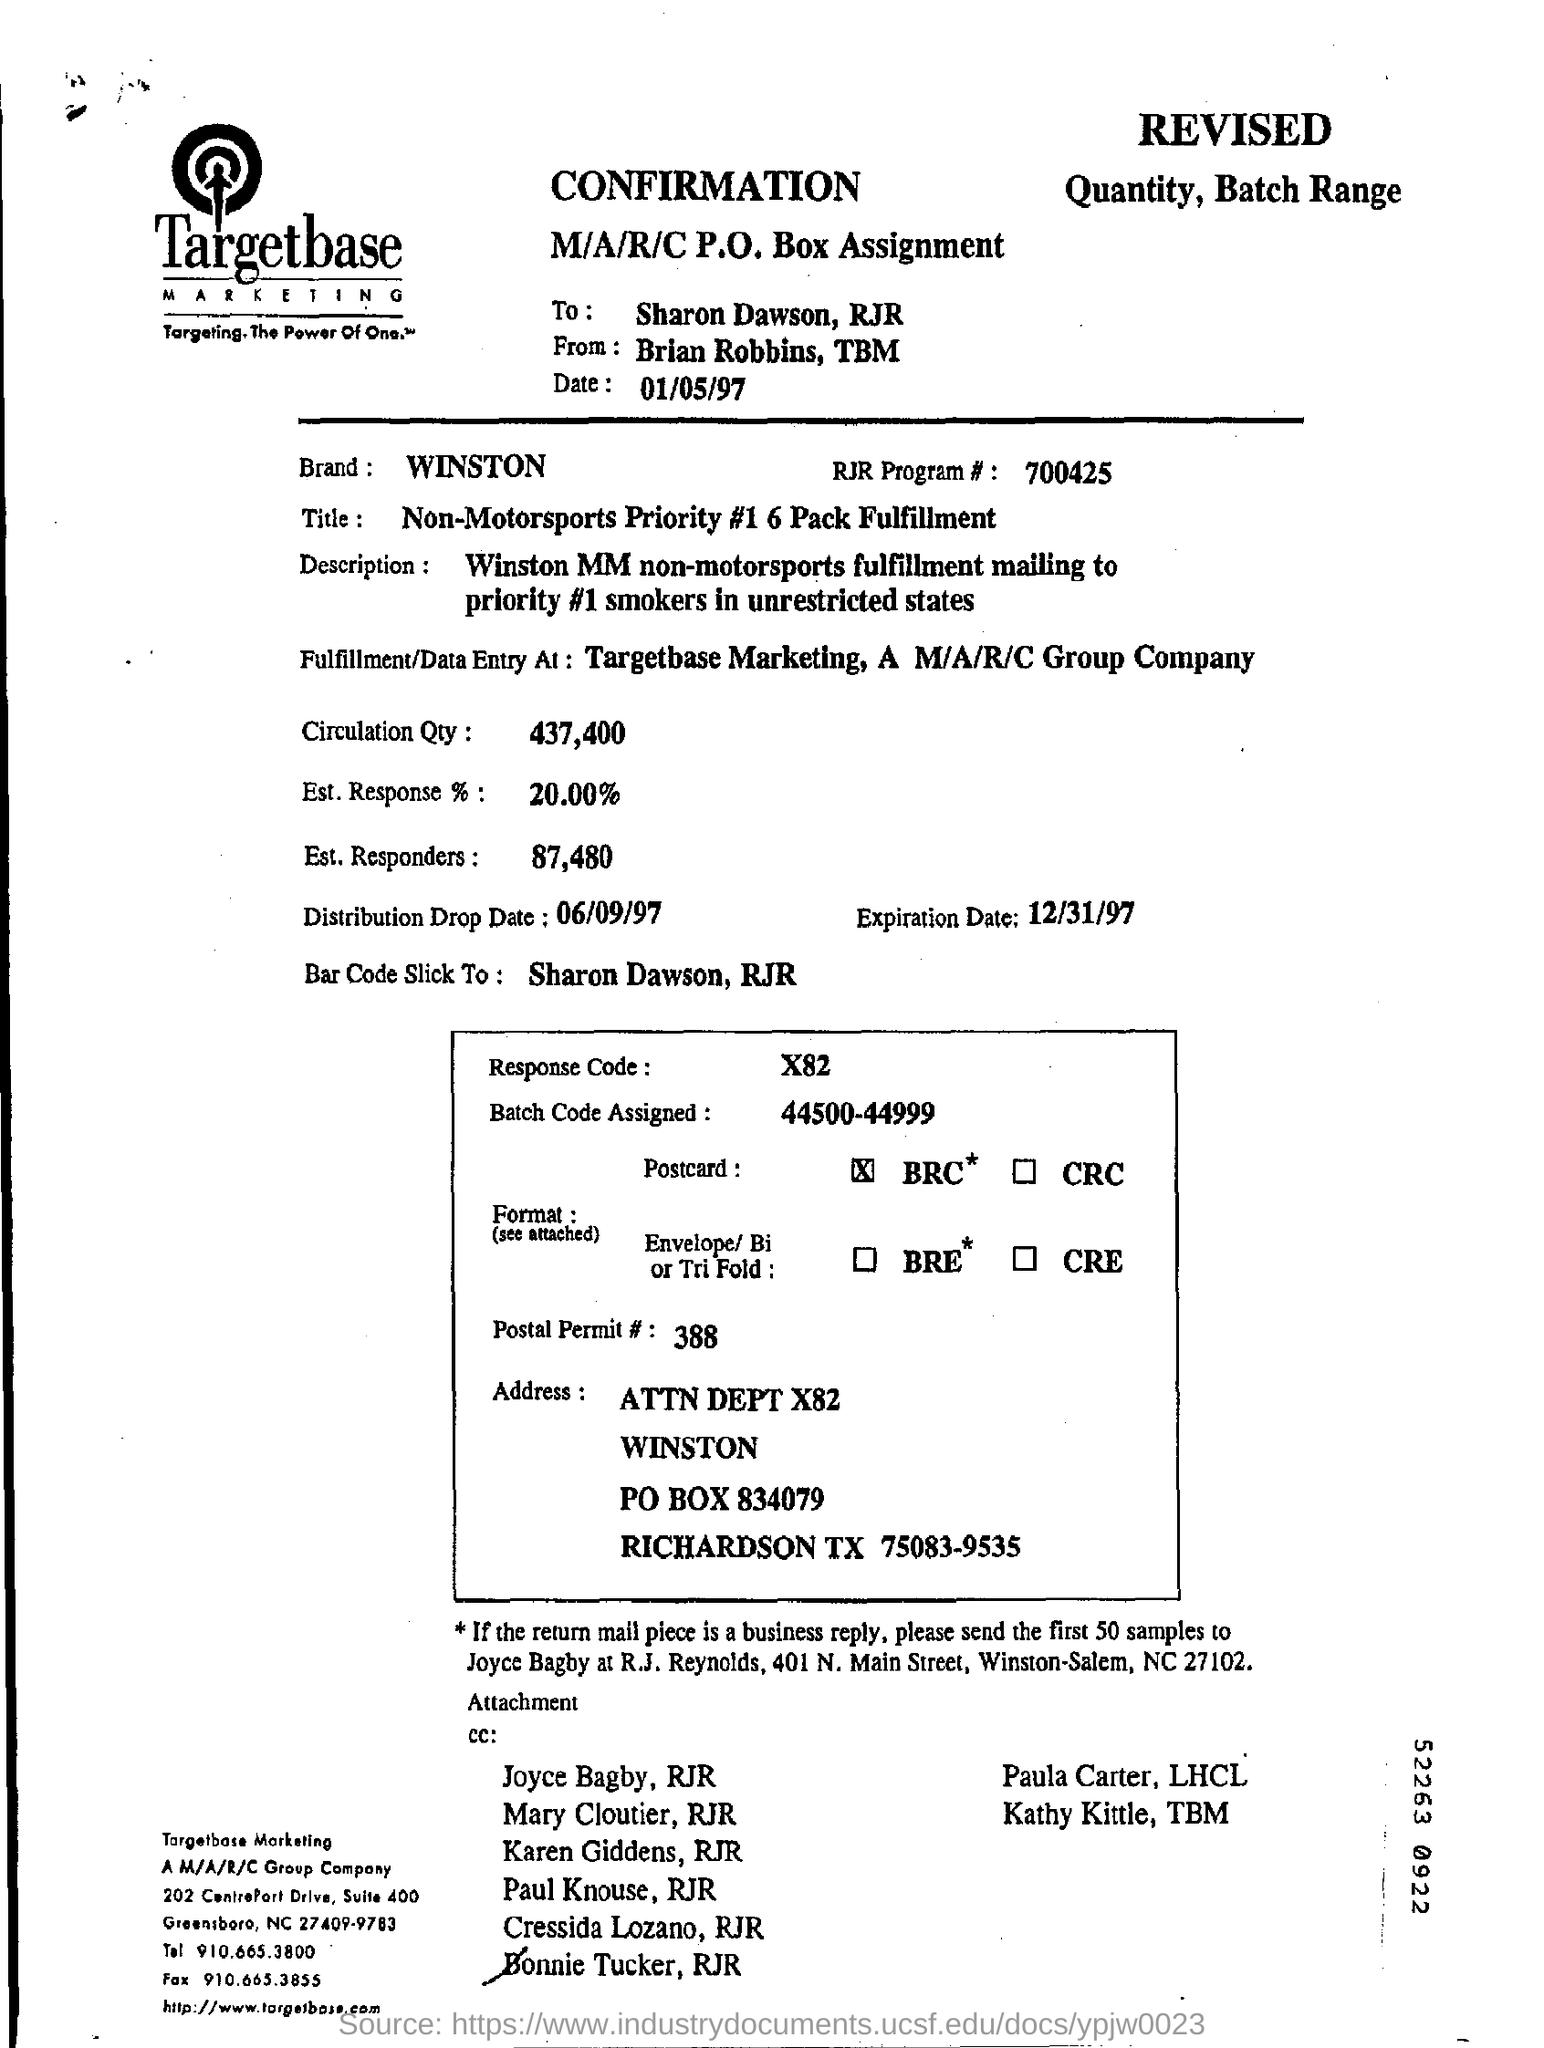Which company's name is at the top of the page?
Offer a very short reply. Targetbase MARKETING. What is the tagline of Targetbase marketing?
Your response must be concise. Targeting.The Power of One. TM. Who is the confirmation addressed to?
Make the answer very short. Sharon Dawson. Which brand is mentioned in the form?
Your answer should be very brief. WINSTON. What is the RJR Program number?
Your answer should be very brief. 700425. What is the title?
Your answer should be compact. Non-Motorsports Priority #1 6 Pack Fulfillment. What is the circulation quantity?
Give a very brief answer. 437,400. What is the estimated response %?
Give a very brief answer. 20.00 %. When is the expiration date?
Offer a terse response. 12/31/97. 